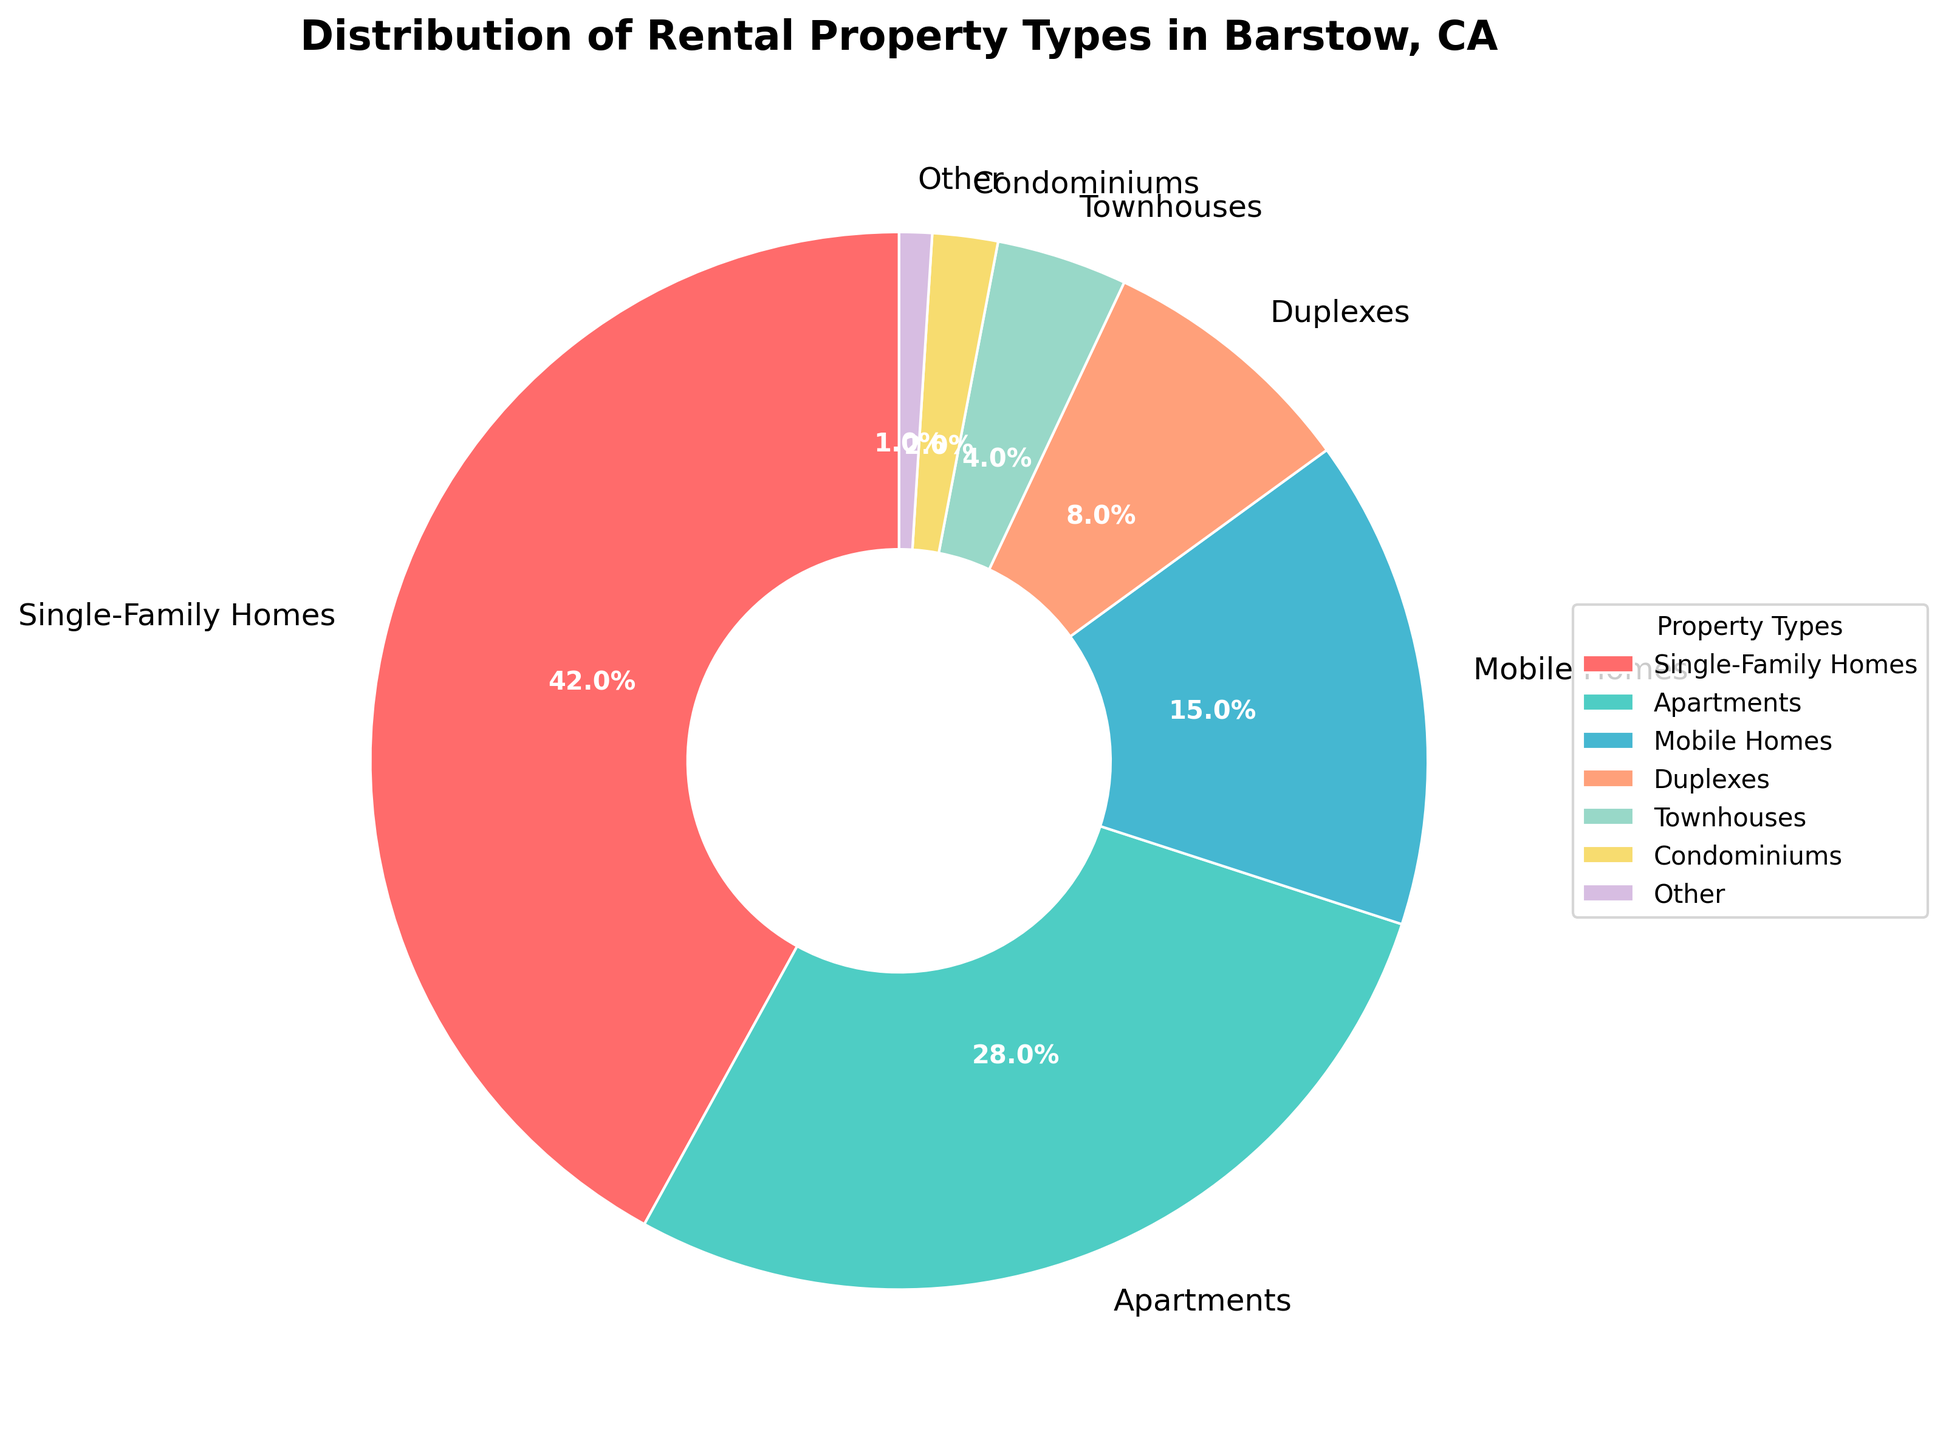What type of rental property is the most common in Barstow, CA? By visual inspection, the largest segment of the pie chart represents Single-Family Homes. The corresponding percentage value verifies that Single-Family Homes take up the largest share at 42%.
Answer: Single-Family Homes Which rental property type has the second highest percentage? The next largest segment after Single-Family Homes represents Apartments. By checking the pie chart segments, Apartments are identified with a percentage of 28%.
Answer: Apartments What is the combined percentage of Mobile Homes, Duplexes, and Townhouses? The pie chart shows Mobile Homes (15%), Duplexes (8%), and Townhouses (4%). Summing these percentages gives 15% + 8% + 4% = 27%.
Answer: 27% How does the percentage of Condominiums compare to Townhouses? According to the pie chart, Condominiums have a 2% share, whereas Townhouses have a 4% share, indicating that Townhouses have a higher percentage.
Answer: Townhouses have a higher percentage What property type fills the smallest segment in the pie chart? By observing the pie chart, the smallest segment corresponds to 'Other' with a percentage of 1%.
Answer: Other How much larger is the percentage of Single-Family Homes compared to Mobile Homes? Single-Family Homes are at 42%, and Mobile Homes are at 15%. The difference is 42% - 15% = 27%.
Answer: 27% Are Apartments or Mobile Homes more common, and by what percentage? Apartments are more common at 28%, while Mobile Homes are at 15%. The difference is 28% - 15% = 13%.
Answer: Apartments by 13% If we combine the percentages of Condominiums and Other, is this combination still less than Duplexes alone? Condominiums are at 2% and Other at 1%. Combined, they are 2% + 1% = 3%, which is less than Duplexes at 8%.
Answer: Yes What proportion of rental property types are less than 10% each? The pie chart shows that Duplexes (8%), Townhouses (4%), Condominiums (2%), and Other (1%) are each below 10%. This makes four distinct property types.
Answer: 4 property types What is the total percentage of rental properties not including Single-Family Homes and Apartments? The total percentage can be calculated as 100% - (Single-Family Homes 42% + Apartments 28%) = 100% - 70% = 30%.
Answer: 30% 